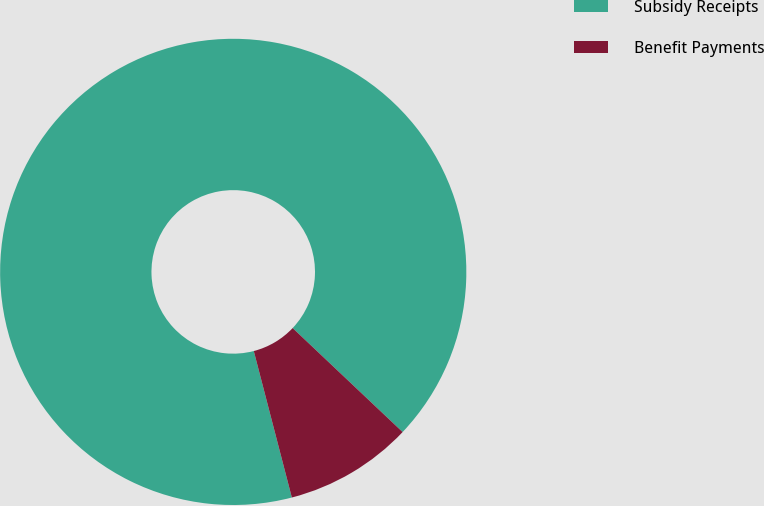<chart> <loc_0><loc_0><loc_500><loc_500><pie_chart><fcel>Subsidy Receipts<fcel>Benefit Payments<nl><fcel>91.1%<fcel>8.9%<nl></chart> 